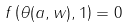Convert formula to latex. <formula><loc_0><loc_0><loc_500><loc_500>f \left ( \theta ( a , w ) , 1 \right ) = 0</formula> 